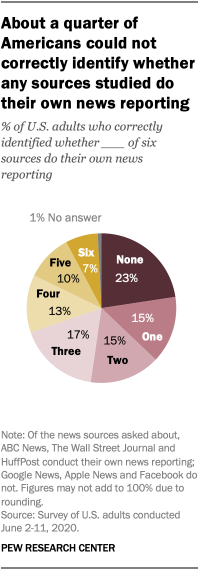Mention a couple of crucial points in this snapshot. The median value of all the segments is 14. The value of the 'None' segment is 23% 